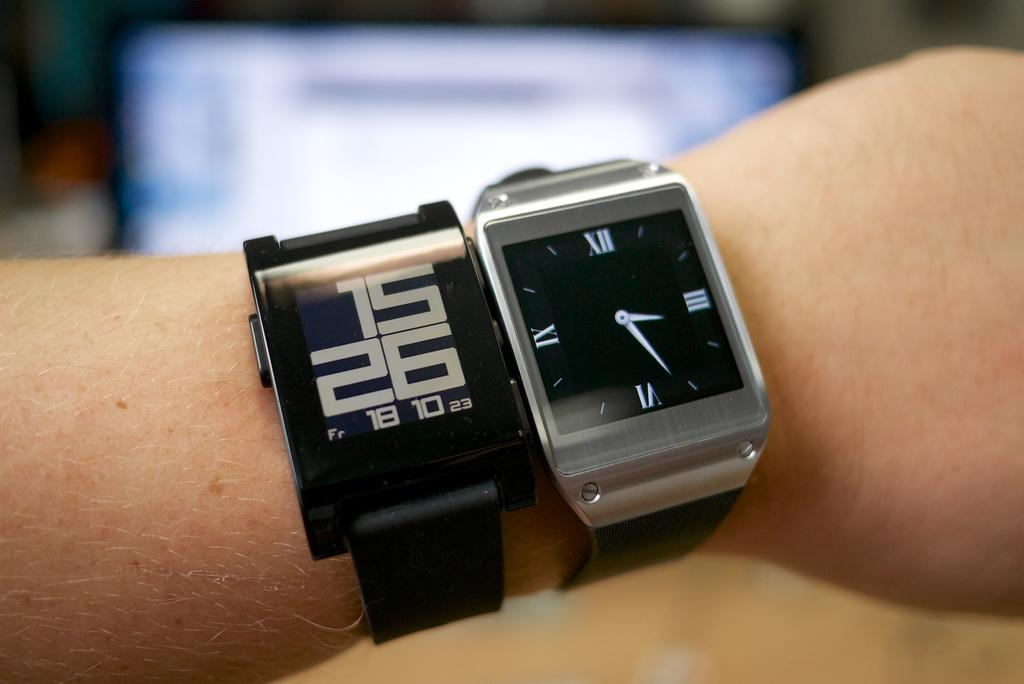<image>
Relay a brief, clear account of the picture shown. A person is wearing two smartwatches that are displaying the time as 15:26. 